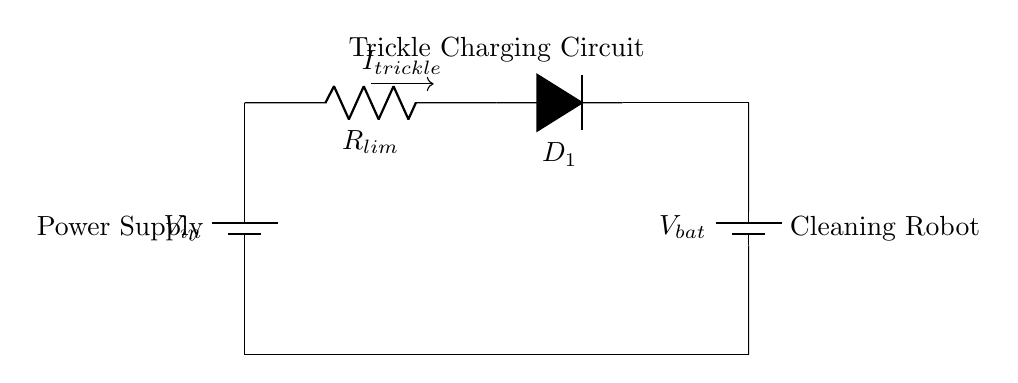What is the component limiting current in the circuit? The component limiting current is the resistor labeled as R_lim, which is designed to limit the current flowing into the battery for safe charging.
Answer: R_lim What is the function of Diode D_1? Diode D_1 ensures that the current flows only in one direction, preventing the battery from discharging back into the power supply.
Answer: Prevents reverse current What is the role of the power supply labeled V_in? The power supply labeled V_in provides the necessary voltage for charging the battery, ensuring it receives the required energy to maintain charge.
Answer: Voltage source How does trickle charging benefit the cleaning robot's battery? Trickle charging maintains the battery charge over an extended period, preventing it from discharging completely and prolonging battery life.
Answer: Prolongs battery life What is the direction of the trickle current denoted as I_trickle? The direction of I_trickle is indicated by the arrow, and it flows from the power supply through the components to the battery, showing the charging path.
Answer: Flows to battery What happens if R_lim is removed from the circuit? Removing R_lim would allow excessive current to flow into the battery, which could damage the battery and reduce its lifespan due to overheating or overcharging.
Answer: Potential battery damage 